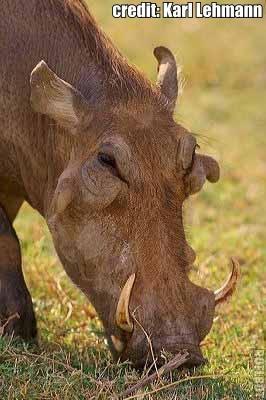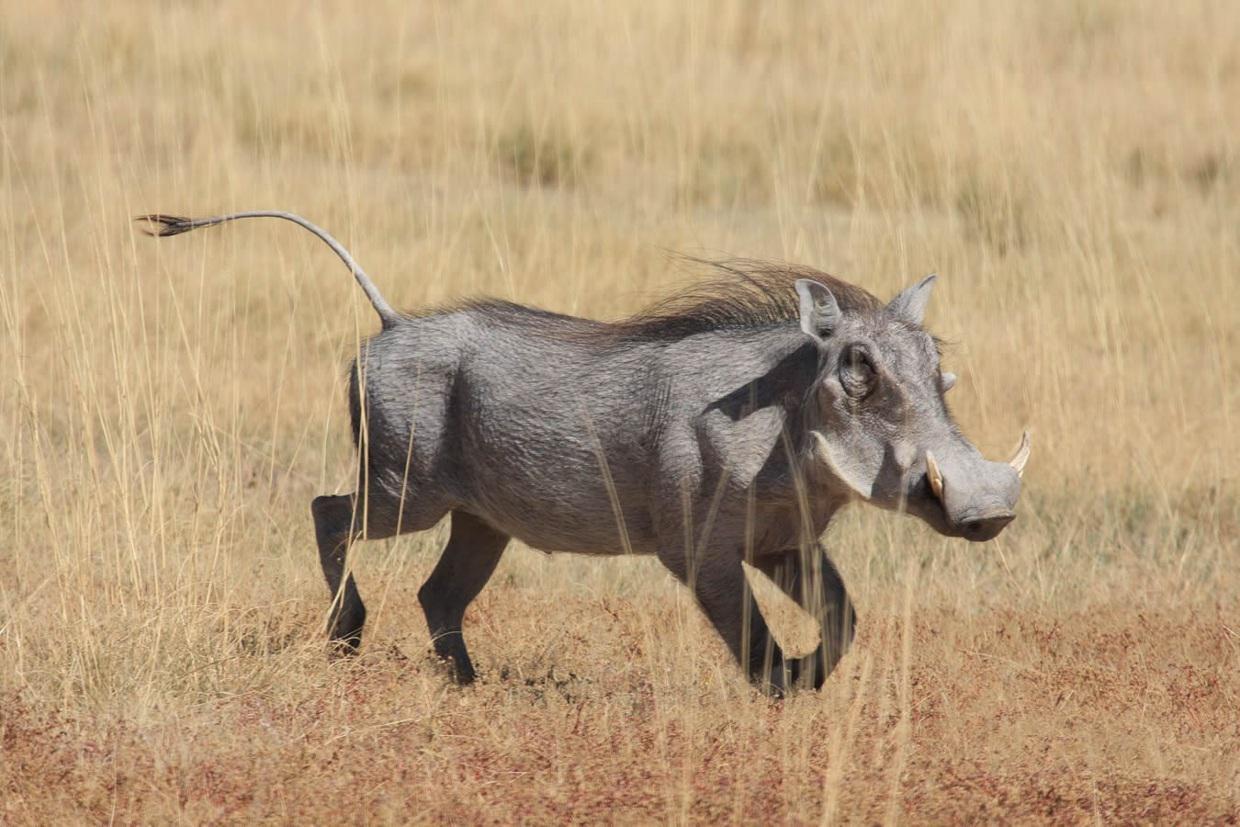The first image is the image on the left, the second image is the image on the right. Considering the images on both sides, is "A hog is near a body of water." valid? Answer yes or no. No. The first image is the image on the left, the second image is the image on the right. For the images shown, is this caption "An image shows at least one warthog in profile, running across a dry field with its tail flying out behind it." true? Answer yes or no. Yes. 